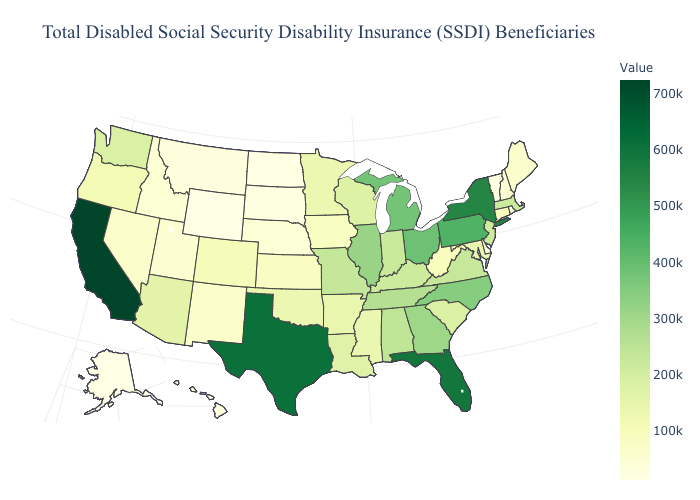Among the states that border New Mexico , does Colorado have the highest value?
Keep it brief. No. Does Ohio have the highest value in the MidWest?
Write a very short answer. Yes. Is the legend a continuous bar?
Keep it brief. Yes. Does the map have missing data?
Give a very brief answer. No. Does Tennessee have the highest value in the USA?
Quick response, please. No. 